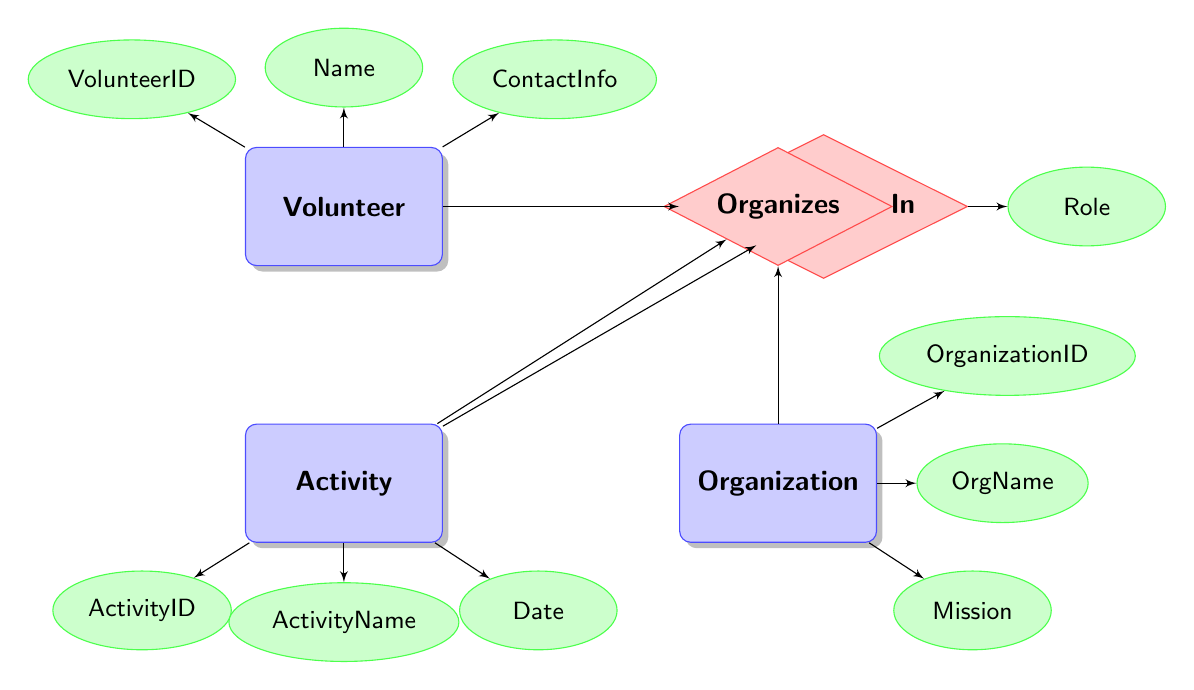What's represented as an entity in the diagram? The diagram includes three entities: Volunteer, Activity, and Organization. Each entity is represented as a distinct box in the diagram.
Answer: Volunteer, Activity, Organization How many attributes does the Activity entity have? The Activity entity has three attributes: ActivityID, ActivityName, and Date. They are shown as ellipses connected to the Activity entity.
Answer: 3 What relationship connects Volunteer and Activity? The relationship that connects Volunteer and Activity is called "Participates In." It is depicted as a diamond shape with lines connecting both entities.
Answer: Participates In What is the role attribute associated with? The role attribute is associated with the Participates In relationship. It indicates the role of a volunteer in a specific activity.
Answer: Participates In Which entity organizes activities? The entity that organizes activities is Organization. It is connected to the Activity entity through the "Organizes" relationship.
Answer: Organization How many relationships are in the diagram? There are two relationships in the diagram: "Participates In" and "Organizes." Each is represented by a diamond shape that connects different entities.
Answer: 2 What is the mission of the Organization entity? The mission of the Organization entity is an attribute called "Mission," represented as an ellipse connected to the Organization box.
Answer: Mission Which entity has the attribute "ContactInfo"? The Volunteer entity has the attribute "ContactInfo," which is connected to it as an ellipse in the diagram.
Answer: Volunteer 